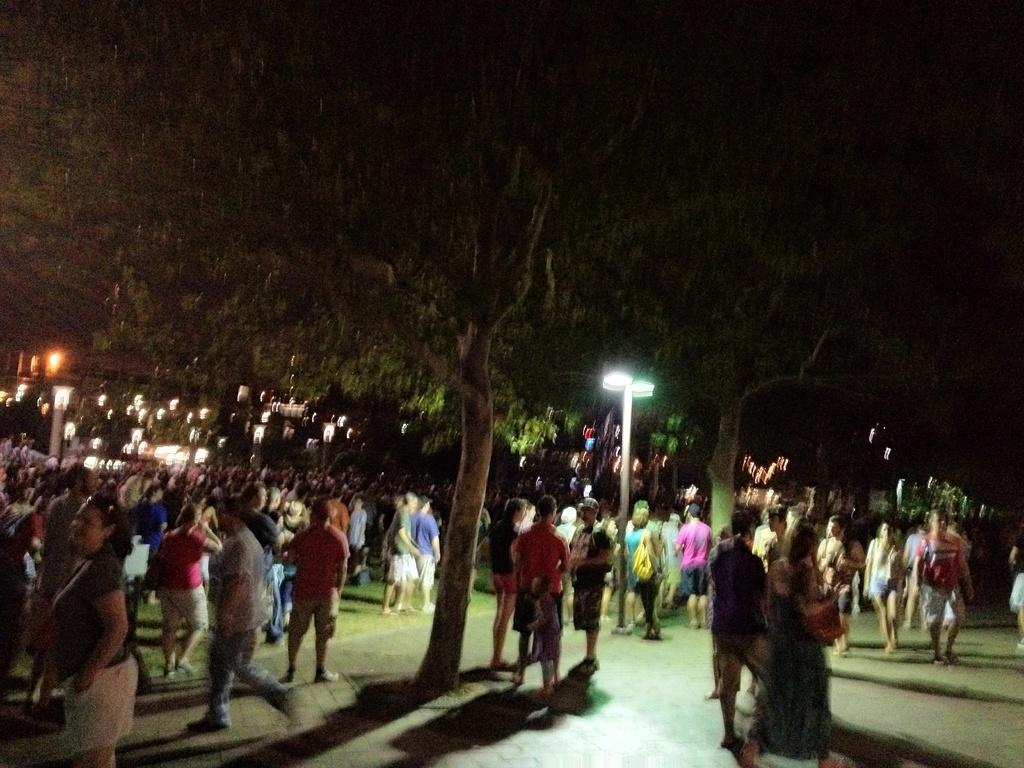How many people are in the image? There are many people in the image. What are the people doing in the image? The people are standing and walking on the land. What type of vegetation can be seen in the image? Trees are present in the image. What can be seen in the background of the image? There are lights in the background. When was the image taken? The image was taken at night time. Can you find the clover growing on the ground in the image? There is no clover present in the image; it features people, trees, and lights at night time. 